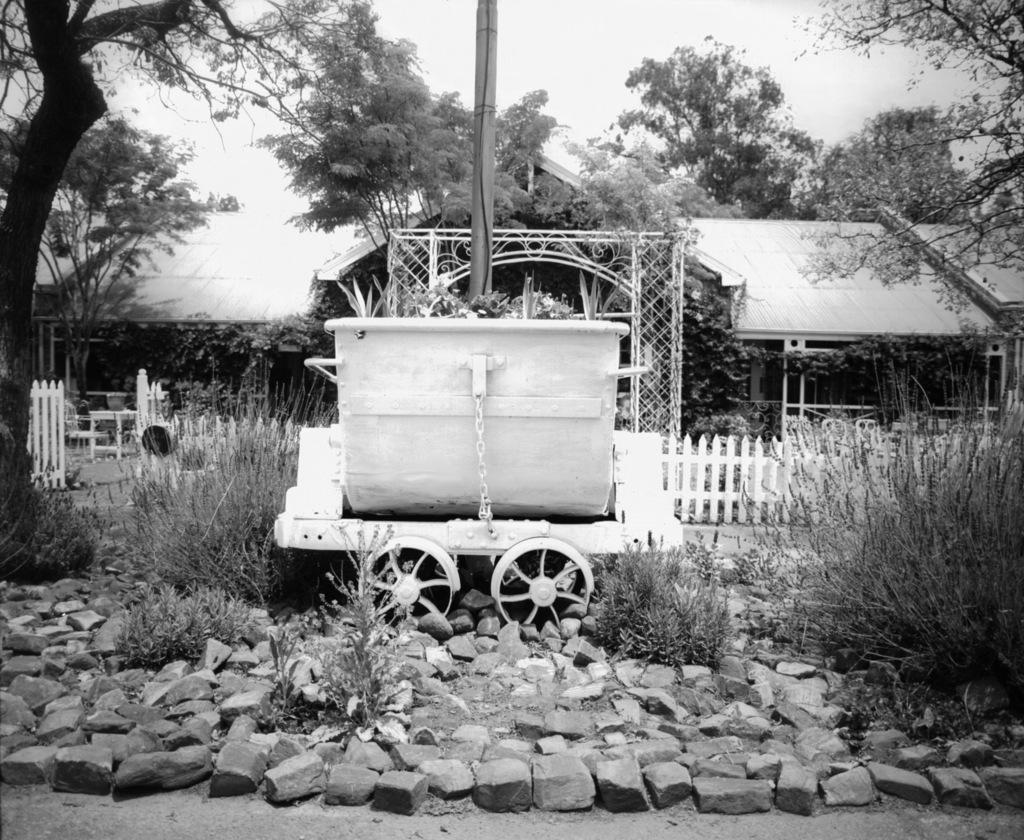What can be seen in the foreground of the image? In the foreground of the image, there are stones, a boat on wheels, and plants. What is located in the background of the image? In the background of the image, there are houses, a boundary, trees, and the sky. What type of transportation is depicted in the image? The image features a boat on wheels in the foreground. What natural elements are present in the image? The image includes plants, trees, and the sky. What type of wood is being used to make the milk in the image? There is no wood or milk present in the image. 